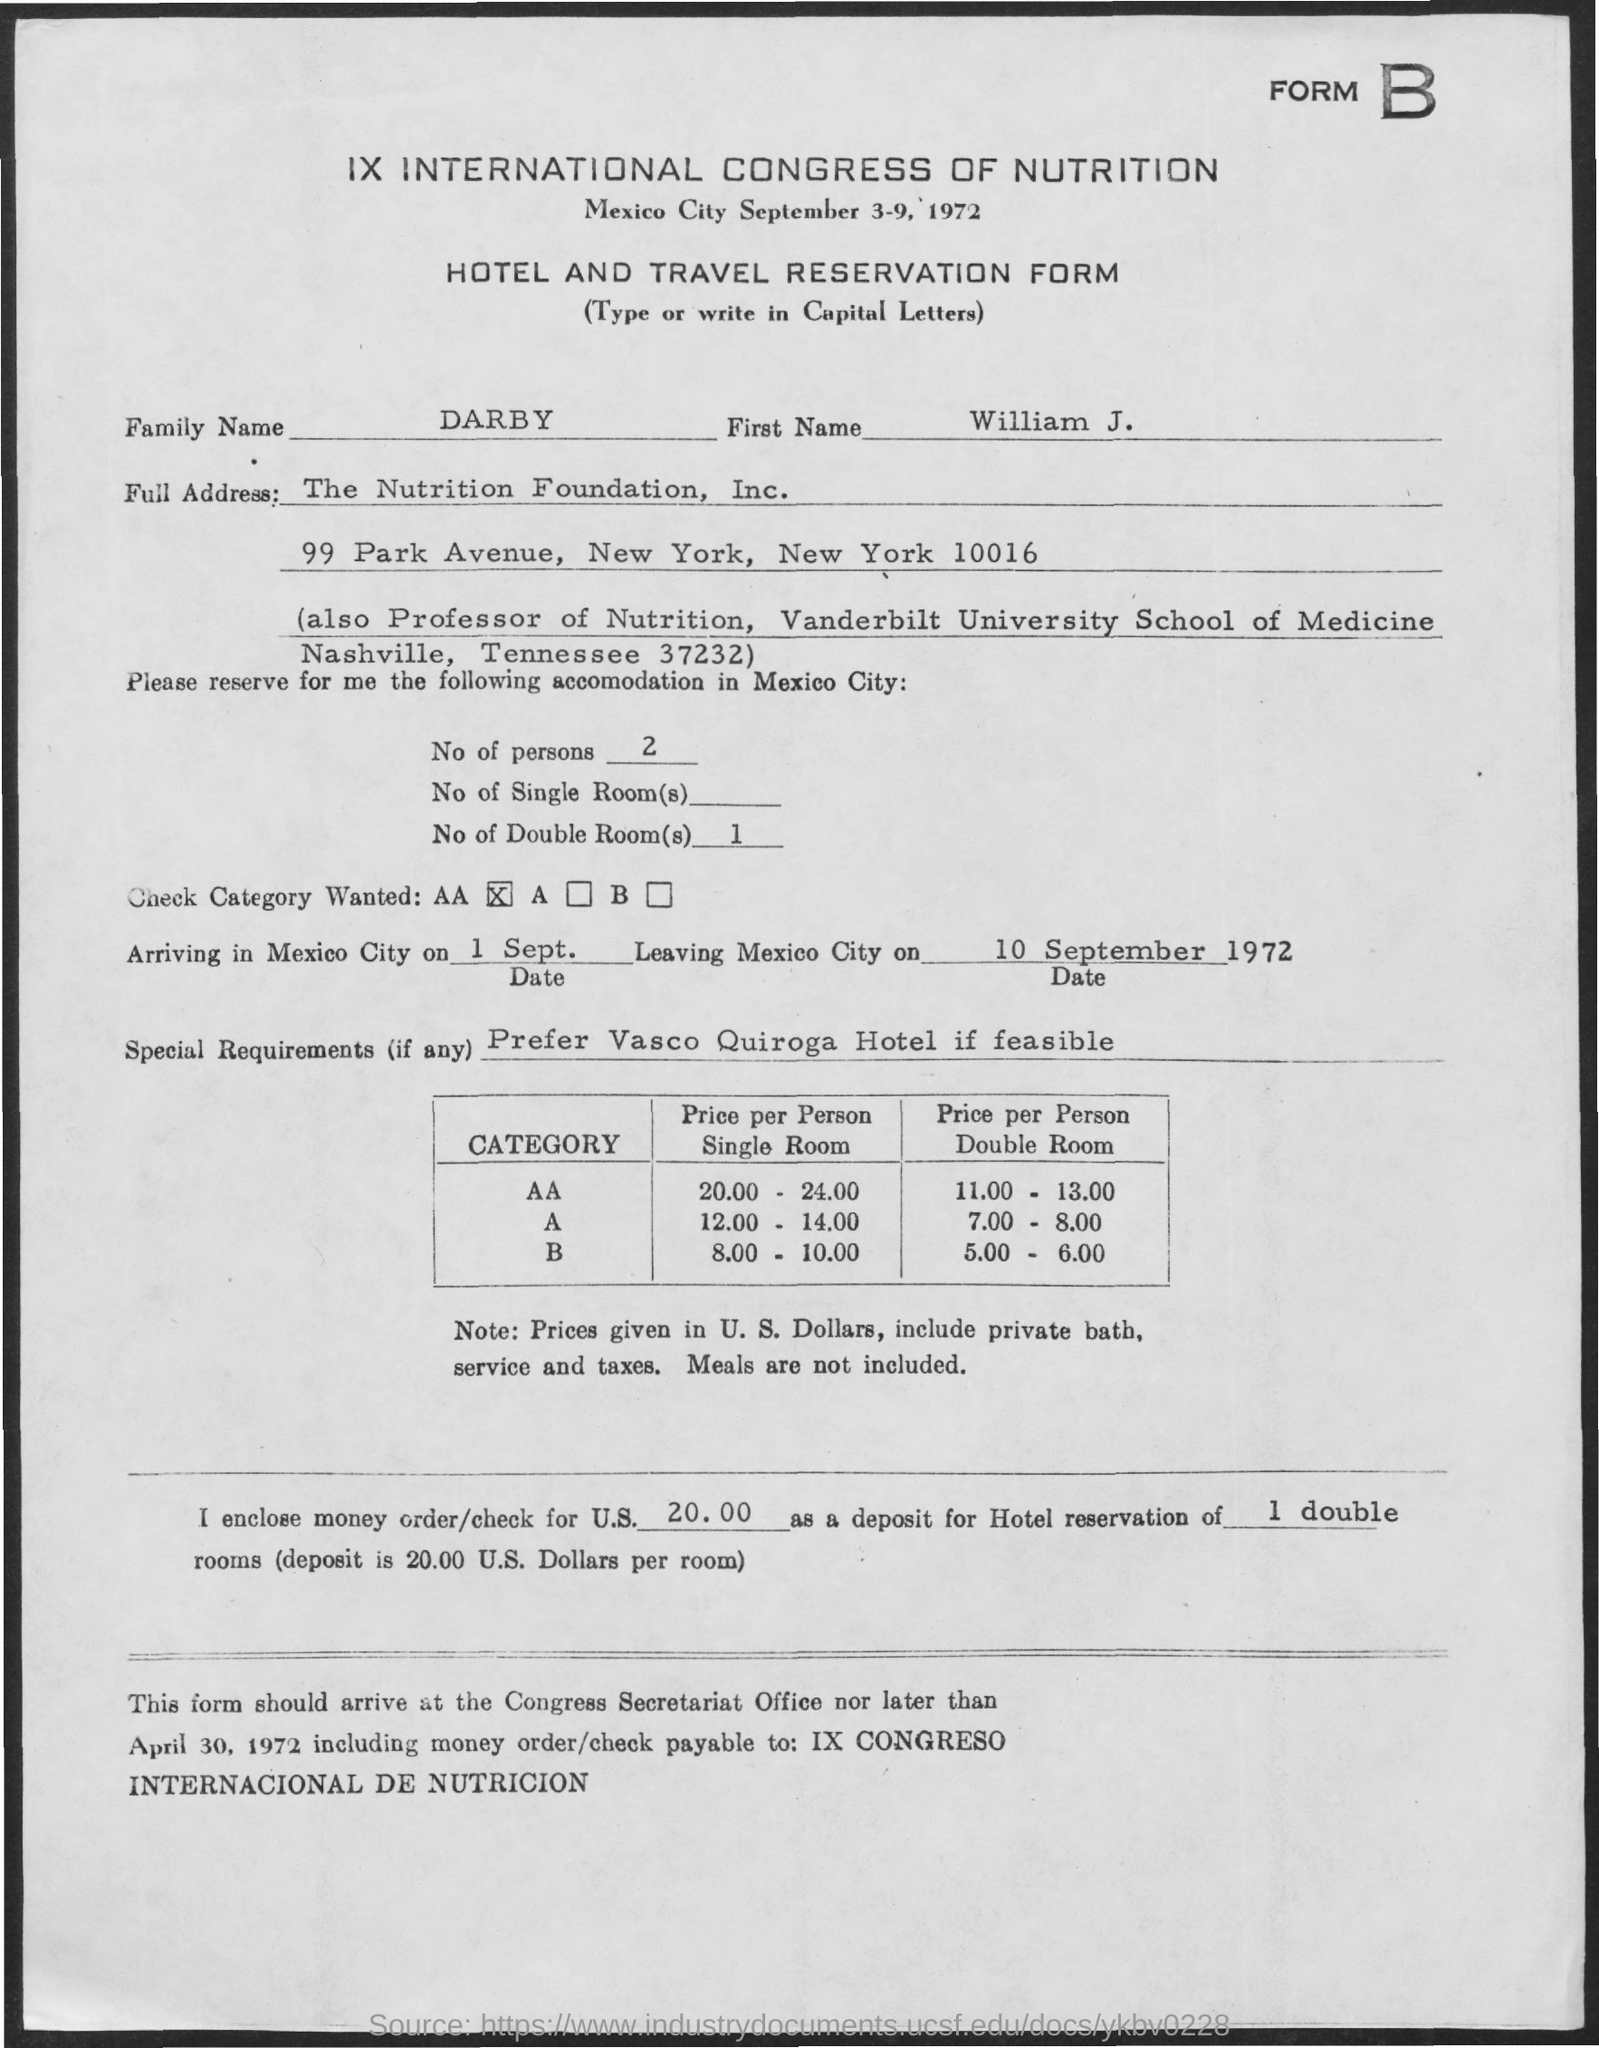What is the family name?
Provide a short and direct response. Darby. What is the first name?
Your response must be concise. William J. 